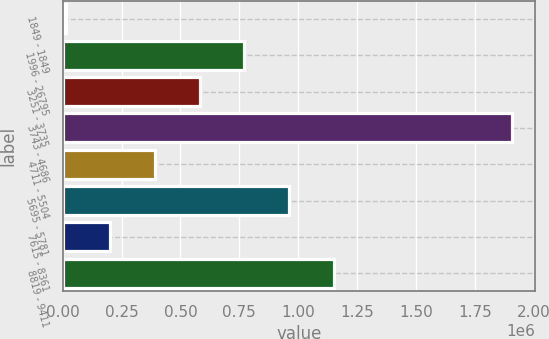<chart> <loc_0><loc_0><loc_500><loc_500><bar_chart><fcel>1849 - 1849<fcel>1996 - 26795<fcel>3251 - 3735<fcel>3743 - 4686<fcel>4711 - 5504<fcel>5695 - 5781<fcel>7615 - 8361<fcel>8819 - 9411<nl><fcel>12000<fcel>770827<fcel>581120<fcel>1.90907e+06<fcel>391414<fcel>960534<fcel>201707<fcel>1.15024e+06<nl></chart> 